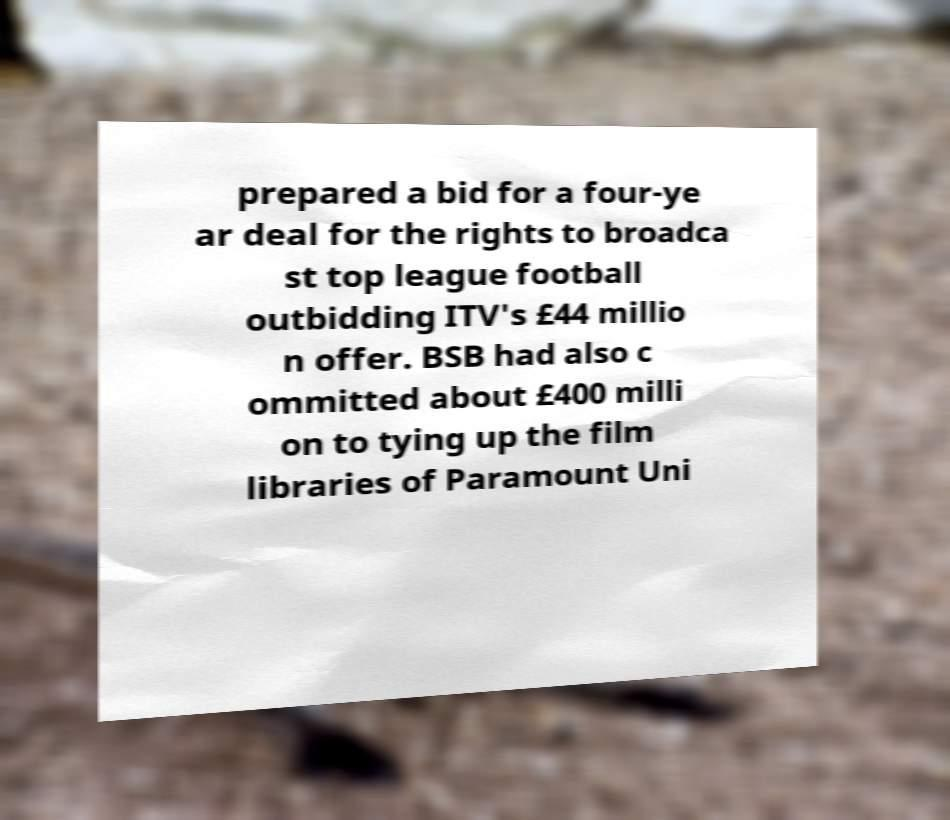Please identify and transcribe the text found in this image. prepared a bid for a four-ye ar deal for the rights to broadca st top league football outbidding ITV's £44 millio n offer. BSB had also c ommitted about £400 milli on to tying up the film libraries of Paramount Uni 